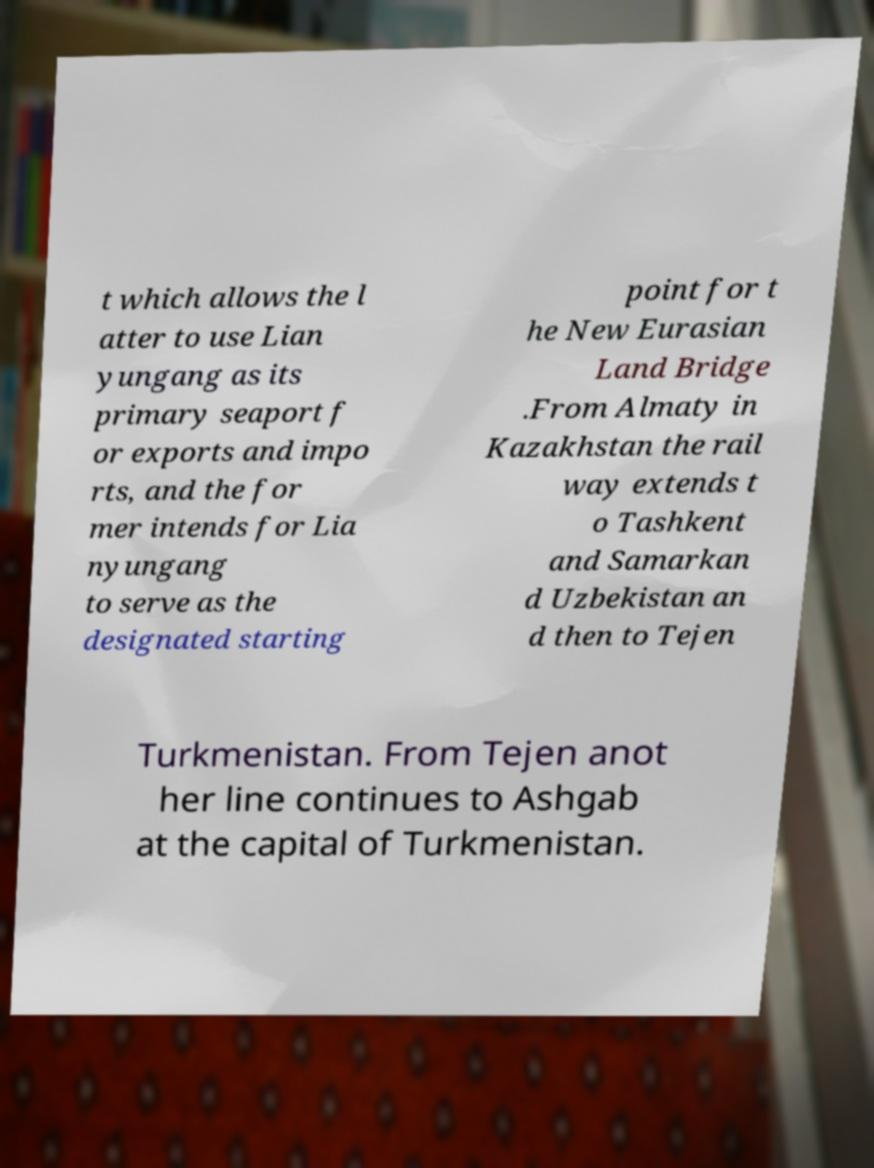Please identify and transcribe the text found in this image. t which allows the l atter to use Lian yungang as its primary seaport f or exports and impo rts, and the for mer intends for Lia nyungang to serve as the designated starting point for t he New Eurasian Land Bridge .From Almaty in Kazakhstan the rail way extends t o Tashkent and Samarkan d Uzbekistan an d then to Tejen Turkmenistan. From Tejen anot her line continues to Ashgab at the capital of Turkmenistan. 